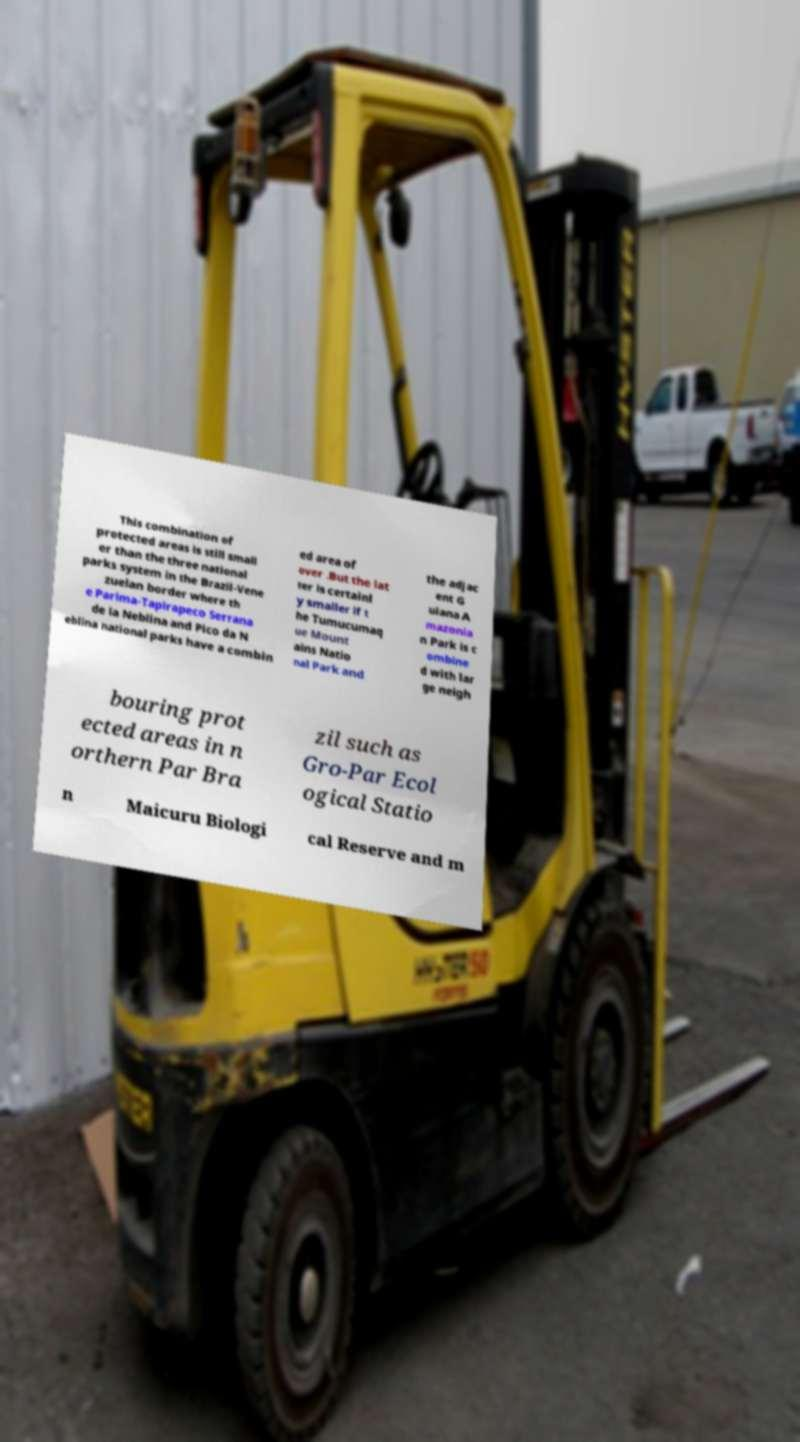There's text embedded in this image that I need extracted. Can you transcribe it verbatim? This combination of protected areas is still small er than the three national parks system in the Brazil-Vene zuelan border where th e Parima-Tapirapeco Serrana de la Neblina and Pico da N eblina national parks have a combin ed area of over .But the lat ter is certainl y smaller if t he Tumucumaq ue Mount ains Natio nal Park and the adjac ent G uiana A mazonia n Park is c ombine d with lar ge neigh bouring prot ected areas in n orthern Par Bra zil such as Gro-Par Ecol ogical Statio n Maicuru Biologi cal Reserve and m 